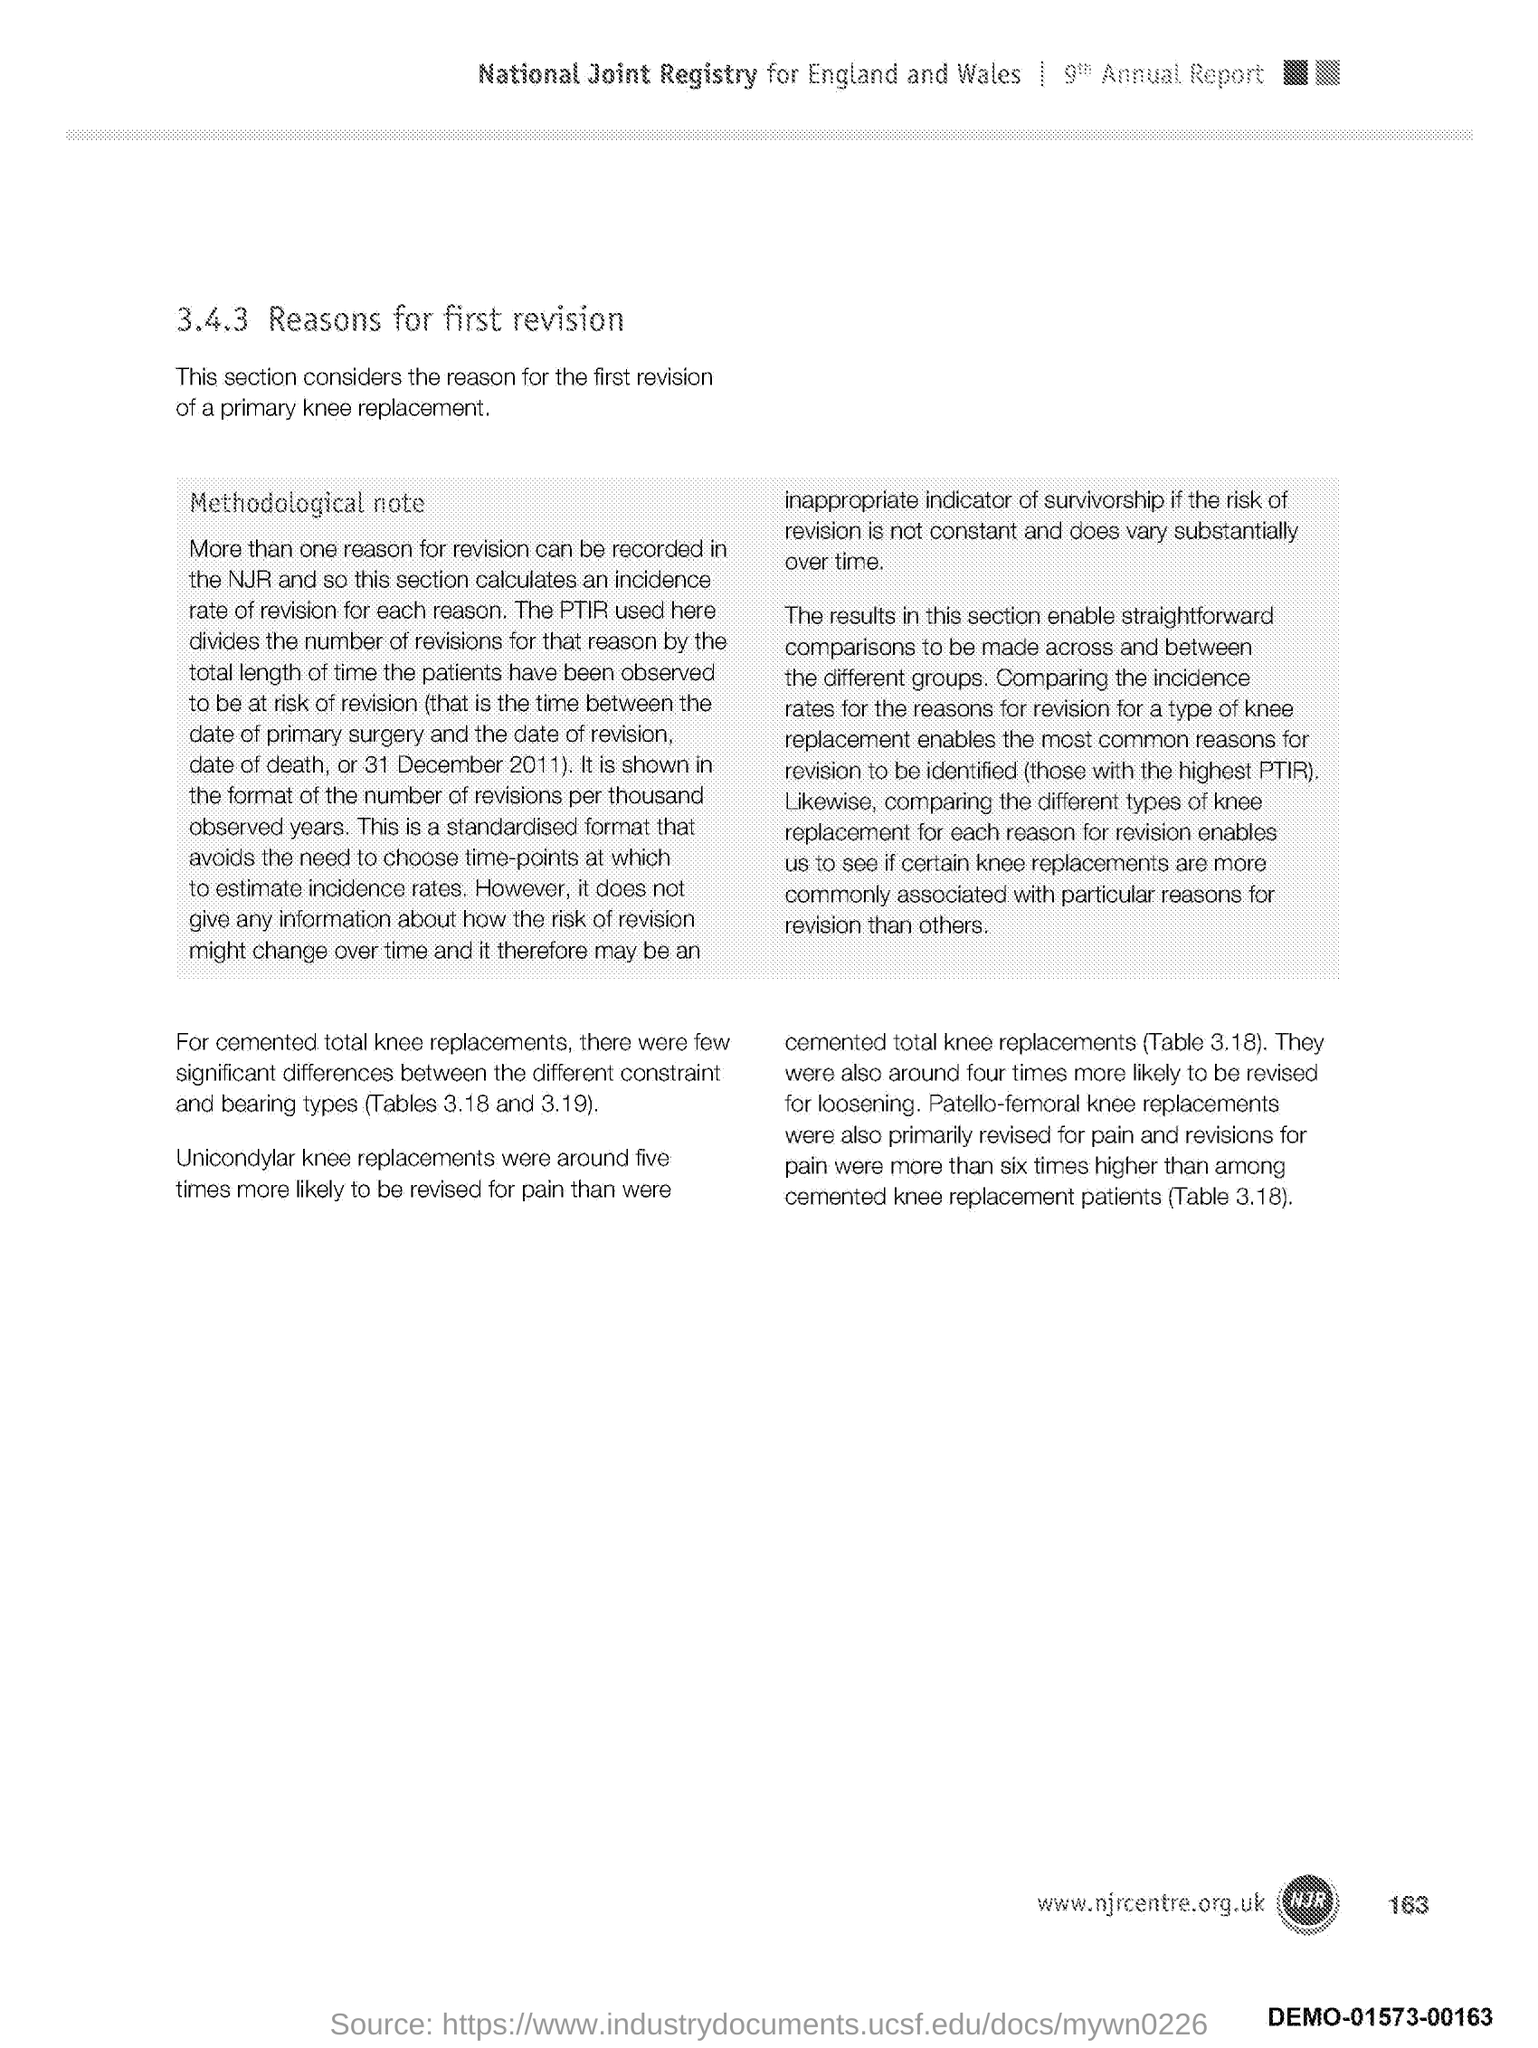What is the number at bottom right side of the page?
Your answer should be compact. 163. 